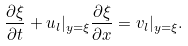Convert formula to latex. <formula><loc_0><loc_0><loc_500><loc_500>\frac { \partial \xi } { \partial t } + u _ { l } | _ { y = \xi } \frac { \partial \xi } { \partial x } = v _ { l } | _ { y = \xi } .</formula> 